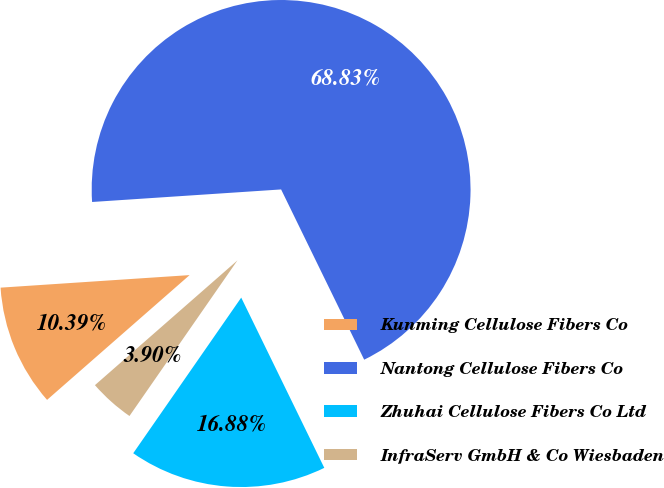Convert chart to OTSL. <chart><loc_0><loc_0><loc_500><loc_500><pie_chart><fcel>Kunming Cellulose Fibers Co<fcel>Nantong Cellulose Fibers Co<fcel>Zhuhai Cellulose Fibers Co Ltd<fcel>InfraServ GmbH & Co Wiesbaden<nl><fcel>10.39%<fcel>68.83%<fcel>16.88%<fcel>3.9%<nl></chart> 